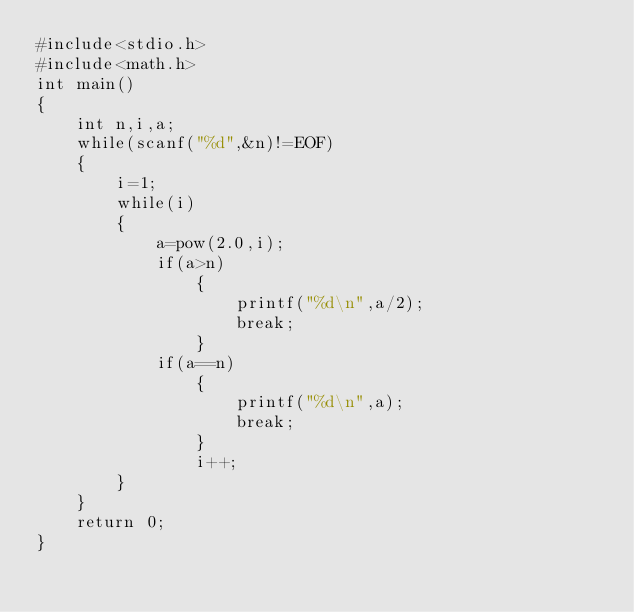Convert code to text. <code><loc_0><loc_0><loc_500><loc_500><_C_>#include<stdio.h>
#include<math.h>
int main()
{
    int n,i,a;
    while(scanf("%d",&n)!=EOF)
    {
        i=1;
        while(i)
        {
            a=pow(2.0,i);
            if(a>n)
                {
                    printf("%d\n",a/2);
                    break;
                }
            if(a==n)
                {
                    printf("%d\n",a);
                    break;
                }
                i++;
        }
    }
    return 0;
}
</code> 